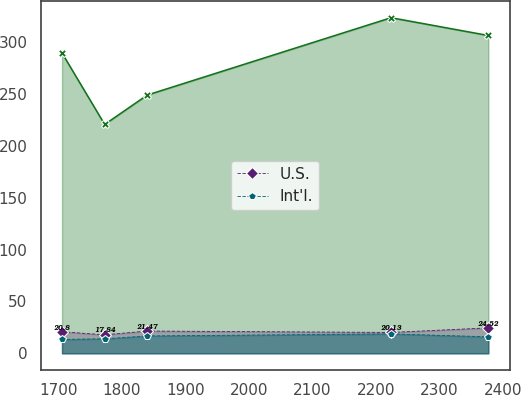Convert chart to OTSL. <chart><loc_0><loc_0><loc_500><loc_500><line_chart><ecel><fcel>Unnamed: 1<fcel>U.S.<fcel>Int'l.<nl><fcel>1705.42<fcel>289.53<fcel>20.8<fcel>13.41<nl><fcel>1772.59<fcel>220.69<fcel>17.84<fcel>14.01<nl><fcel>1839.76<fcel>249.05<fcel>21.47<fcel>16.76<nl><fcel>2223.83<fcel>323.6<fcel>20.13<fcel>18.7<nl><fcel>2377.08<fcel>306.45<fcel>24.52<fcel>15.92<nl></chart> 